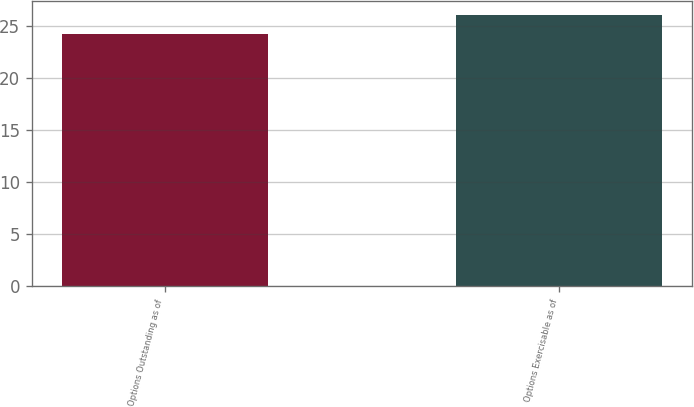Convert chart to OTSL. <chart><loc_0><loc_0><loc_500><loc_500><bar_chart><fcel>Options Outstanding as of<fcel>Options Exercisable as of<nl><fcel>24.19<fcel>26.04<nl></chart> 